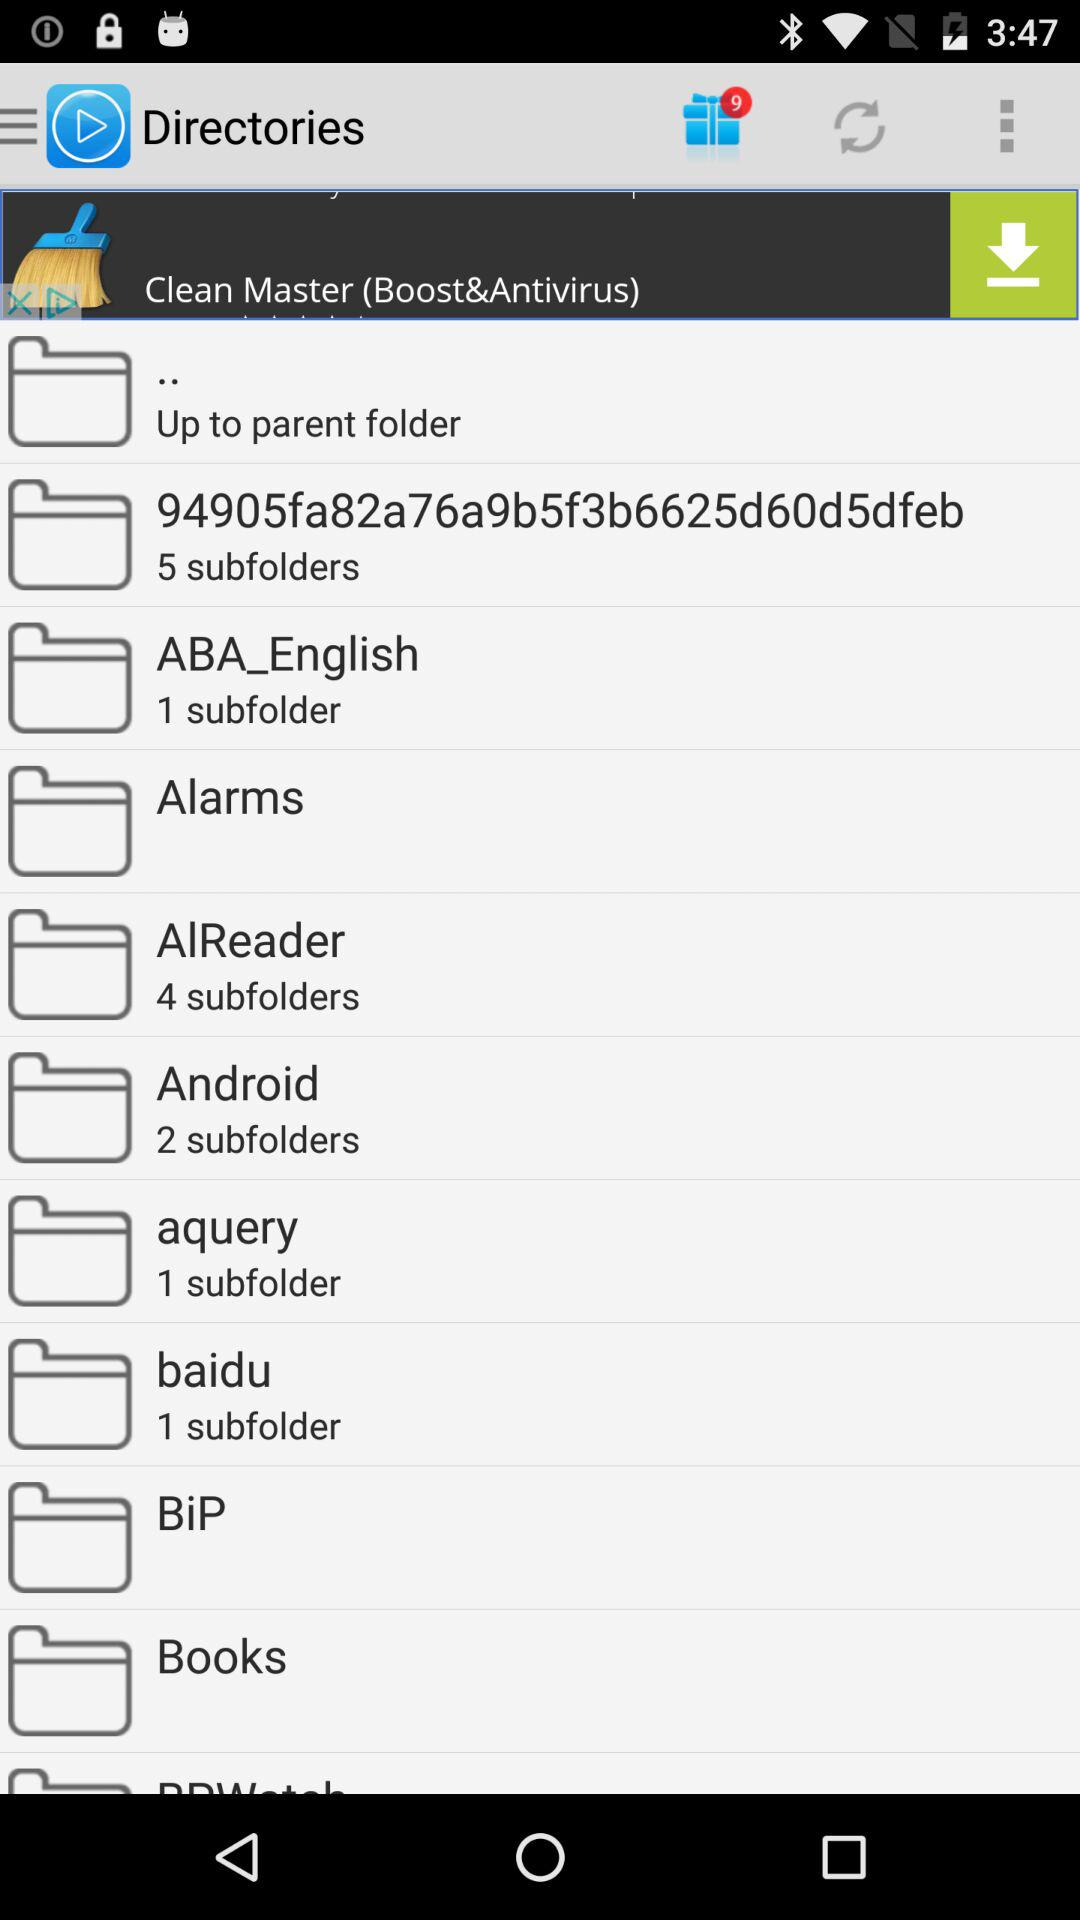How many subfolders does the folder '94905fa82a76a9b5f3b6625d60d5dfeb' have?
Answer the question using a single word or phrase. 5 